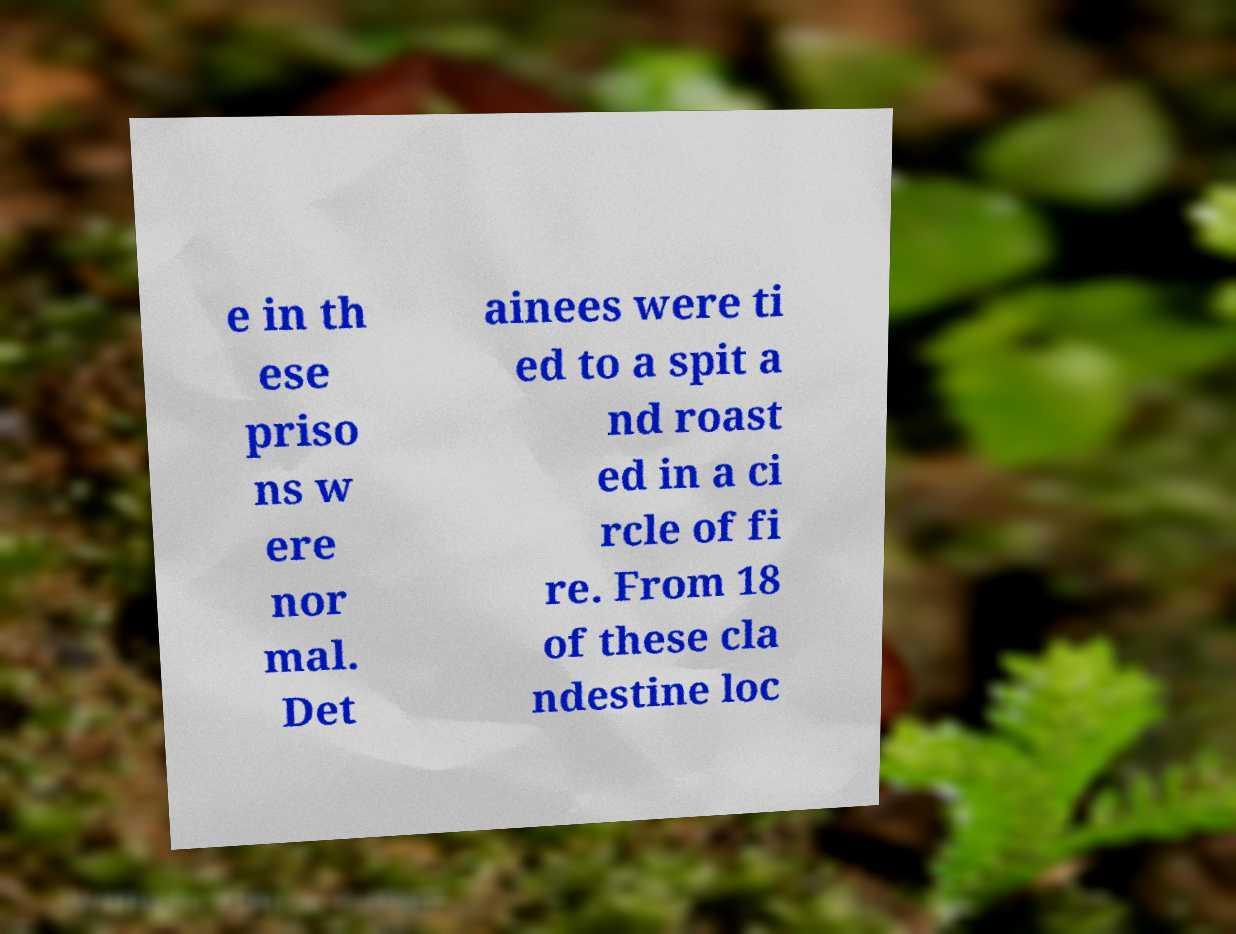Could you extract and type out the text from this image? e in th ese priso ns w ere nor mal. Det ainees were ti ed to a spit a nd roast ed in a ci rcle of fi re. From 18 of these cla ndestine loc 